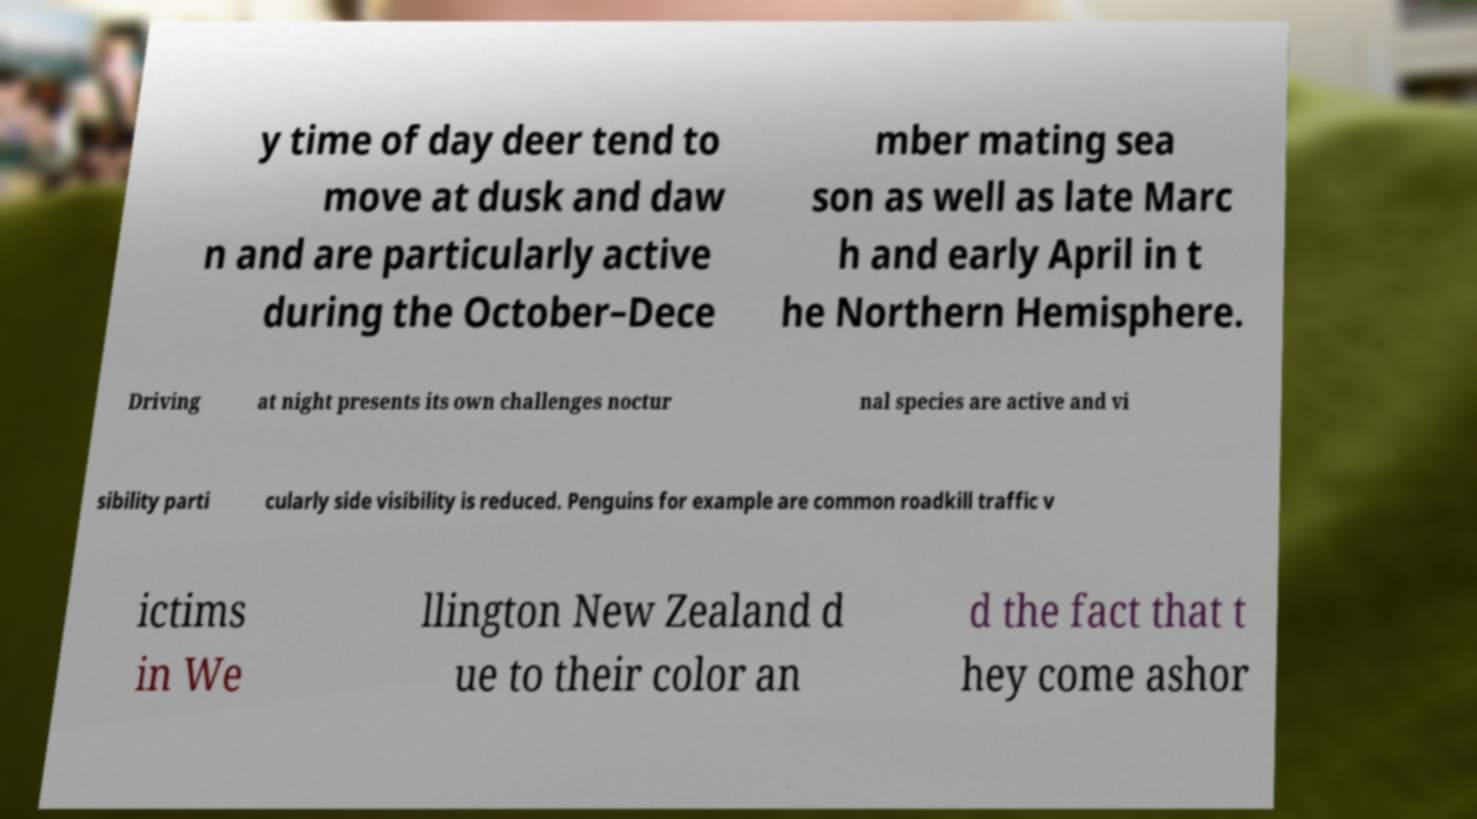What messages or text are displayed in this image? I need them in a readable, typed format. y time of day deer tend to move at dusk and daw n and are particularly active during the October–Dece mber mating sea son as well as late Marc h and early April in t he Northern Hemisphere. Driving at night presents its own challenges noctur nal species are active and vi sibility parti cularly side visibility is reduced. Penguins for example are common roadkill traffic v ictims in We llington New Zealand d ue to their color an d the fact that t hey come ashor 